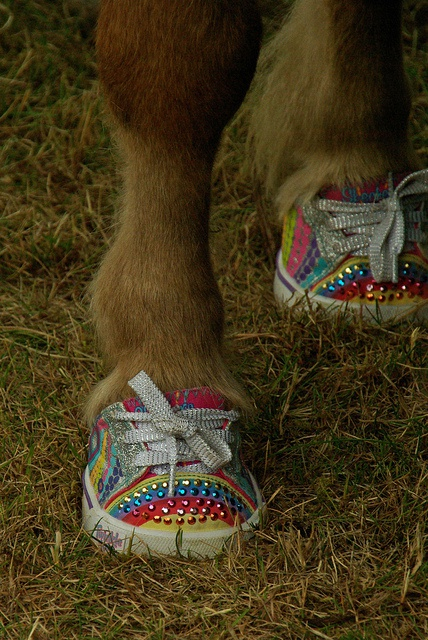Describe the objects in this image and their specific colors. I can see a horse in black, olive, maroon, and gray tones in this image. 